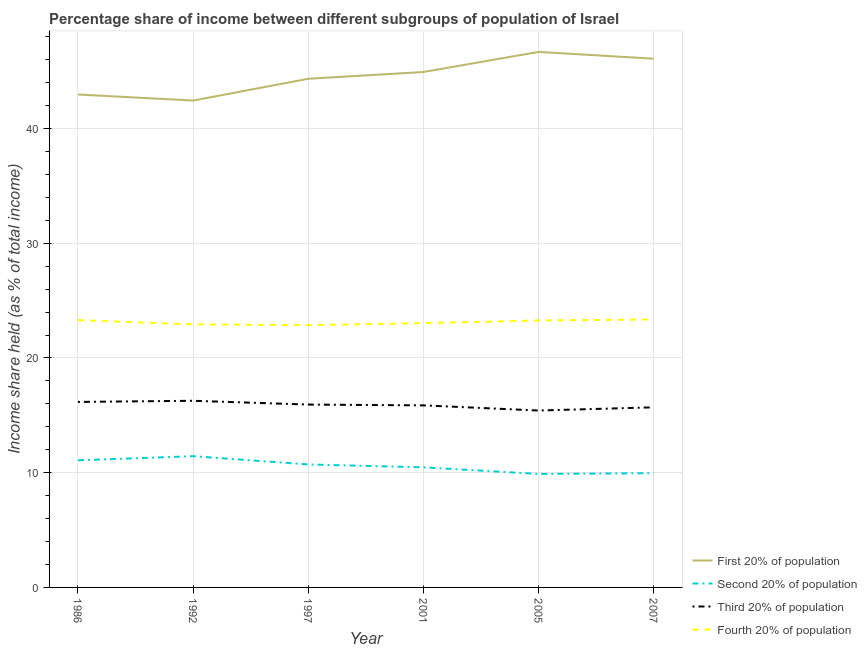Does the line corresponding to share of the income held by third 20% of the population intersect with the line corresponding to share of the income held by second 20% of the population?
Make the answer very short. No. Is the number of lines equal to the number of legend labels?
Your answer should be very brief. Yes. What is the share of the income held by fourth 20% of the population in 2001?
Keep it short and to the point. 23.04. Across all years, what is the maximum share of the income held by first 20% of the population?
Your answer should be very brief. 46.68. Across all years, what is the minimum share of the income held by third 20% of the population?
Provide a succinct answer. 15.42. In which year was the share of the income held by third 20% of the population maximum?
Offer a very short reply. 1992. In which year was the share of the income held by third 20% of the population minimum?
Offer a very short reply. 2005. What is the total share of the income held by third 20% of the population in the graph?
Keep it short and to the point. 95.37. What is the difference between the share of the income held by fourth 20% of the population in 1986 and that in 1992?
Keep it short and to the point. 0.37. What is the difference between the share of the income held by second 20% of the population in 1992 and the share of the income held by first 20% of the population in 2001?
Provide a short and direct response. -33.49. What is the average share of the income held by fourth 20% of the population per year?
Provide a succinct answer. 23.13. In the year 2001, what is the difference between the share of the income held by first 20% of the population and share of the income held by second 20% of the population?
Provide a succinct answer. 34.46. What is the ratio of the share of the income held by third 20% of the population in 2001 to that in 2007?
Keep it short and to the point. 1.01. What is the difference between the highest and the second highest share of the income held by fourth 20% of the population?
Offer a terse response. 0.06. What is the difference between the highest and the lowest share of the income held by third 20% of the population?
Offer a terse response. 0.85. Is it the case that in every year, the sum of the share of the income held by first 20% of the population and share of the income held by second 20% of the population is greater than the share of the income held by third 20% of the population?
Provide a short and direct response. Yes. Is the share of the income held by first 20% of the population strictly less than the share of the income held by third 20% of the population over the years?
Your response must be concise. No. How many lines are there?
Make the answer very short. 4. What is the difference between two consecutive major ticks on the Y-axis?
Provide a short and direct response. 10. Are the values on the major ticks of Y-axis written in scientific E-notation?
Offer a very short reply. No. Does the graph contain any zero values?
Provide a succinct answer. No. Does the graph contain grids?
Make the answer very short. Yes. How are the legend labels stacked?
Ensure brevity in your answer.  Vertical. What is the title of the graph?
Ensure brevity in your answer.  Percentage share of income between different subgroups of population of Israel. Does "Korea" appear as one of the legend labels in the graph?
Ensure brevity in your answer.  No. What is the label or title of the Y-axis?
Ensure brevity in your answer.  Income share held (as % of total income). What is the Income share held (as % of total income) in First 20% of population in 1986?
Provide a succinct answer. 42.97. What is the Income share held (as % of total income) in Second 20% of population in 1986?
Offer a very short reply. 11.08. What is the Income share held (as % of total income) of Third 20% of population in 1986?
Give a very brief answer. 16.17. What is the Income share held (as % of total income) in Fourth 20% of population in 1986?
Your response must be concise. 23.3. What is the Income share held (as % of total income) in First 20% of population in 1992?
Provide a short and direct response. 42.44. What is the Income share held (as % of total income) in Second 20% of population in 1992?
Ensure brevity in your answer.  11.44. What is the Income share held (as % of total income) of Third 20% of population in 1992?
Ensure brevity in your answer.  16.27. What is the Income share held (as % of total income) of Fourth 20% of population in 1992?
Offer a very short reply. 22.93. What is the Income share held (as % of total income) in First 20% of population in 1997?
Give a very brief answer. 44.34. What is the Income share held (as % of total income) in Second 20% of population in 1997?
Ensure brevity in your answer.  10.72. What is the Income share held (as % of total income) of Third 20% of population in 1997?
Your answer should be compact. 15.94. What is the Income share held (as % of total income) of Fourth 20% of population in 1997?
Your answer should be compact. 22.86. What is the Income share held (as % of total income) of First 20% of population in 2001?
Offer a terse response. 44.93. What is the Income share held (as % of total income) of Second 20% of population in 2001?
Give a very brief answer. 10.47. What is the Income share held (as % of total income) of Third 20% of population in 2001?
Keep it short and to the point. 15.87. What is the Income share held (as % of total income) of Fourth 20% of population in 2001?
Ensure brevity in your answer.  23.04. What is the Income share held (as % of total income) of First 20% of population in 2005?
Keep it short and to the point. 46.68. What is the Income share held (as % of total income) in Second 20% of population in 2005?
Your answer should be compact. 9.89. What is the Income share held (as % of total income) in Third 20% of population in 2005?
Offer a terse response. 15.42. What is the Income share held (as % of total income) of Fourth 20% of population in 2005?
Offer a very short reply. 23.27. What is the Income share held (as % of total income) in First 20% of population in 2007?
Your answer should be compact. 46.09. What is the Income share held (as % of total income) in Second 20% of population in 2007?
Ensure brevity in your answer.  9.96. What is the Income share held (as % of total income) of Third 20% of population in 2007?
Provide a short and direct response. 15.7. What is the Income share held (as % of total income) of Fourth 20% of population in 2007?
Provide a succinct answer. 23.36. Across all years, what is the maximum Income share held (as % of total income) in First 20% of population?
Your answer should be very brief. 46.68. Across all years, what is the maximum Income share held (as % of total income) of Second 20% of population?
Provide a succinct answer. 11.44. Across all years, what is the maximum Income share held (as % of total income) in Third 20% of population?
Your response must be concise. 16.27. Across all years, what is the maximum Income share held (as % of total income) of Fourth 20% of population?
Offer a terse response. 23.36. Across all years, what is the minimum Income share held (as % of total income) in First 20% of population?
Your response must be concise. 42.44. Across all years, what is the minimum Income share held (as % of total income) in Second 20% of population?
Your response must be concise. 9.89. Across all years, what is the minimum Income share held (as % of total income) in Third 20% of population?
Provide a succinct answer. 15.42. Across all years, what is the minimum Income share held (as % of total income) in Fourth 20% of population?
Make the answer very short. 22.86. What is the total Income share held (as % of total income) in First 20% of population in the graph?
Offer a terse response. 267.45. What is the total Income share held (as % of total income) of Second 20% of population in the graph?
Ensure brevity in your answer.  63.56. What is the total Income share held (as % of total income) in Third 20% of population in the graph?
Make the answer very short. 95.37. What is the total Income share held (as % of total income) of Fourth 20% of population in the graph?
Offer a very short reply. 138.76. What is the difference between the Income share held (as % of total income) of First 20% of population in 1986 and that in 1992?
Your answer should be very brief. 0.53. What is the difference between the Income share held (as % of total income) of Second 20% of population in 1986 and that in 1992?
Provide a succinct answer. -0.36. What is the difference between the Income share held (as % of total income) of Third 20% of population in 1986 and that in 1992?
Give a very brief answer. -0.1. What is the difference between the Income share held (as % of total income) in Fourth 20% of population in 1986 and that in 1992?
Make the answer very short. 0.37. What is the difference between the Income share held (as % of total income) of First 20% of population in 1986 and that in 1997?
Offer a very short reply. -1.37. What is the difference between the Income share held (as % of total income) in Second 20% of population in 1986 and that in 1997?
Give a very brief answer. 0.36. What is the difference between the Income share held (as % of total income) of Third 20% of population in 1986 and that in 1997?
Your response must be concise. 0.23. What is the difference between the Income share held (as % of total income) of Fourth 20% of population in 1986 and that in 1997?
Make the answer very short. 0.44. What is the difference between the Income share held (as % of total income) in First 20% of population in 1986 and that in 2001?
Your answer should be very brief. -1.96. What is the difference between the Income share held (as % of total income) in Second 20% of population in 1986 and that in 2001?
Provide a short and direct response. 0.61. What is the difference between the Income share held (as % of total income) of Fourth 20% of population in 1986 and that in 2001?
Provide a succinct answer. 0.26. What is the difference between the Income share held (as % of total income) of First 20% of population in 1986 and that in 2005?
Your answer should be compact. -3.71. What is the difference between the Income share held (as % of total income) in Second 20% of population in 1986 and that in 2005?
Keep it short and to the point. 1.19. What is the difference between the Income share held (as % of total income) of Fourth 20% of population in 1986 and that in 2005?
Offer a very short reply. 0.03. What is the difference between the Income share held (as % of total income) in First 20% of population in 1986 and that in 2007?
Keep it short and to the point. -3.12. What is the difference between the Income share held (as % of total income) in Second 20% of population in 1986 and that in 2007?
Make the answer very short. 1.12. What is the difference between the Income share held (as % of total income) of Third 20% of population in 1986 and that in 2007?
Ensure brevity in your answer.  0.47. What is the difference between the Income share held (as % of total income) of Fourth 20% of population in 1986 and that in 2007?
Offer a terse response. -0.06. What is the difference between the Income share held (as % of total income) of First 20% of population in 1992 and that in 1997?
Provide a short and direct response. -1.9. What is the difference between the Income share held (as % of total income) in Second 20% of population in 1992 and that in 1997?
Make the answer very short. 0.72. What is the difference between the Income share held (as % of total income) of Third 20% of population in 1992 and that in 1997?
Give a very brief answer. 0.33. What is the difference between the Income share held (as % of total income) in Fourth 20% of population in 1992 and that in 1997?
Provide a succinct answer. 0.07. What is the difference between the Income share held (as % of total income) of First 20% of population in 1992 and that in 2001?
Offer a terse response. -2.49. What is the difference between the Income share held (as % of total income) of Second 20% of population in 1992 and that in 2001?
Keep it short and to the point. 0.97. What is the difference between the Income share held (as % of total income) in Fourth 20% of population in 1992 and that in 2001?
Your answer should be very brief. -0.11. What is the difference between the Income share held (as % of total income) in First 20% of population in 1992 and that in 2005?
Ensure brevity in your answer.  -4.24. What is the difference between the Income share held (as % of total income) of Second 20% of population in 1992 and that in 2005?
Ensure brevity in your answer.  1.55. What is the difference between the Income share held (as % of total income) of Third 20% of population in 1992 and that in 2005?
Keep it short and to the point. 0.85. What is the difference between the Income share held (as % of total income) in Fourth 20% of population in 1992 and that in 2005?
Your answer should be compact. -0.34. What is the difference between the Income share held (as % of total income) of First 20% of population in 1992 and that in 2007?
Keep it short and to the point. -3.65. What is the difference between the Income share held (as % of total income) in Second 20% of population in 1992 and that in 2007?
Keep it short and to the point. 1.48. What is the difference between the Income share held (as % of total income) of Third 20% of population in 1992 and that in 2007?
Your response must be concise. 0.57. What is the difference between the Income share held (as % of total income) of Fourth 20% of population in 1992 and that in 2007?
Offer a very short reply. -0.43. What is the difference between the Income share held (as % of total income) in First 20% of population in 1997 and that in 2001?
Provide a succinct answer. -0.59. What is the difference between the Income share held (as % of total income) in Second 20% of population in 1997 and that in 2001?
Offer a very short reply. 0.25. What is the difference between the Income share held (as % of total income) of Third 20% of population in 1997 and that in 2001?
Make the answer very short. 0.07. What is the difference between the Income share held (as % of total income) of Fourth 20% of population in 1997 and that in 2001?
Your response must be concise. -0.18. What is the difference between the Income share held (as % of total income) in First 20% of population in 1997 and that in 2005?
Keep it short and to the point. -2.34. What is the difference between the Income share held (as % of total income) of Second 20% of population in 1997 and that in 2005?
Offer a terse response. 0.83. What is the difference between the Income share held (as % of total income) of Third 20% of population in 1997 and that in 2005?
Make the answer very short. 0.52. What is the difference between the Income share held (as % of total income) of Fourth 20% of population in 1997 and that in 2005?
Keep it short and to the point. -0.41. What is the difference between the Income share held (as % of total income) of First 20% of population in 1997 and that in 2007?
Your response must be concise. -1.75. What is the difference between the Income share held (as % of total income) of Second 20% of population in 1997 and that in 2007?
Provide a short and direct response. 0.76. What is the difference between the Income share held (as % of total income) of Third 20% of population in 1997 and that in 2007?
Make the answer very short. 0.24. What is the difference between the Income share held (as % of total income) in Fourth 20% of population in 1997 and that in 2007?
Provide a succinct answer. -0.5. What is the difference between the Income share held (as % of total income) of First 20% of population in 2001 and that in 2005?
Offer a terse response. -1.75. What is the difference between the Income share held (as % of total income) of Second 20% of population in 2001 and that in 2005?
Offer a very short reply. 0.58. What is the difference between the Income share held (as % of total income) in Third 20% of population in 2001 and that in 2005?
Offer a very short reply. 0.45. What is the difference between the Income share held (as % of total income) in Fourth 20% of population in 2001 and that in 2005?
Ensure brevity in your answer.  -0.23. What is the difference between the Income share held (as % of total income) of First 20% of population in 2001 and that in 2007?
Offer a terse response. -1.16. What is the difference between the Income share held (as % of total income) in Second 20% of population in 2001 and that in 2007?
Your response must be concise. 0.51. What is the difference between the Income share held (as % of total income) of Third 20% of population in 2001 and that in 2007?
Your answer should be compact. 0.17. What is the difference between the Income share held (as % of total income) of Fourth 20% of population in 2001 and that in 2007?
Your answer should be compact. -0.32. What is the difference between the Income share held (as % of total income) of First 20% of population in 2005 and that in 2007?
Provide a succinct answer. 0.59. What is the difference between the Income share held (as % of total income) of Second 20% of population in 2005 and that in 2007?
Offer a terse response. -0.07. What is the difference between the Income share held (as % of total income) of Third 20% of population in 2005 and that in 2007?
Make the answer very short. -0.28. What is the difference between the Income share held (as % of total income) of Fourth 20% of population in 2005 and that in 2007?
Your answer should be compact. -0.09. What is the difference between the Income share held (as % of total income) in First 20% of population in 1986 and the Income share held (as % of total income) in Second 20% of population in 1992?
Provide a succinct answer. 31.53. What is the difference between the Income share held (as % of total income) of First 20% of population in 1986 and the Income share held (as % of total income) of Third 20% of population in 1992?
Your answer should be very brief. 26.7. What is the difference between the Income share held (as % of total income) of First 20% of population in 1986 and the Income share held (as % of total income) of Fourth 20% of population in 1992?
Your answer should be very brief. 20.04. What is the difference between the Income share held (as % of total income) in Second 20% of population in 1986 and the Income share held (as % of total income) in Third 20% of population in 1992?
Your answer should be very brief. -5.19. What is the difference between the Income share held (as % of total income) in Second 20% of population in 1986 and the Income share held (as % of total income) in Fourth 20% of population in 1992?
Offer a very short reply. -11.85. What is the difference between the Income share held (as % of total income) in Third 20% of population in 1986 and the Income share held (as % of total income) in Fourth 20% of population in 1992?
Offer a very short reply. -6.76. What is the difference between the Income share held (as % of total income) in First 20% of population in 1986 and the Income share held (as % of total income) in Second 20% of population in 1997?
Give a very brief answer. 32.25. What is the difference between the Income share held (as % of total income) in First 20% of population in 1986 and the Income share held (as % of total income) in Third 20% of population in 1997?
Your response must be concise. 27.03. What is the difference between the Income share held (as % of total income) in First 20% of population in 1986 and the Income share held (as % of total income) in Fourth 20% of population in 1997?
Offer a terse response. 20.11. What is the difference between the Income share held (as % of total income) in Second 20% of population in 1986 and the Income share held (as % of total income) in Third 20% of population in 1997?
Keep it short and to the point. -4.86. What is the difference between the Income share held (as % of total income) in Second 20% of population in 1986 and the Income share held (as % of total income) in Fourth 20% of population in 1997?
Give a very brief answer. -11.78. What is the difference between the Income share held (as % of total income) in Third 20% of population in 1986 and the Income share held (as % of total income) in Fourth 20% of population in 1997?
Provide a succinct answer. -6.69. What is the difference between the Income share held (as % of total income) of First 20% of population in 1986 and the Income share held (as % of total income) of Second 20% of population in 2001?
Provide a succinct answer. 32.5. What is the difference between the Income share held (as % of total income) in First 20% of population in 1986 and the Income share held (as % of total income) in Third 20% of population in 2001?
Your answer should be compact. 27.1. What is the difference between the Income share held (as % of total income) of First 20% of population in 1986 and the Income share held (as % of total income) of Fourth 20% of population in 2001?
Offer a very short reply. 19.93. What is the difference between the Income share held (as % of total income) of Second 20% of population in 1986 and the Income share held (as % of total income) of Third 20% of population in 2001?
Your answer should be compact. -4.79. What is the difference between the Income share held (as % of total income) in Second 20% of population in 1986 and the Income share held (as % of total income) in Fourth 20% of population in 2001?
Your answer should be compact. -11.96. What is the difference between the Income share held (as % of total income) of Third 20% of population in 1986 and the Income share held (as % of total income) of Fourth 20% of population in 2001?
Provide a succinct answer. -6.87. What is the difference between the Income share held (as % of total income) in First 20% of population in 1986 and the Income share held (as % of total income) in Second 20% of population in 2005?
Provide a short and direct response. 33.08. What is the difference between the Income share held (as % of total income) of First 20% of population in 1986 and the Income share held (as % of total income) of Third 20% of population in 2005?
Give a very brief answer. 27.55. What is the difference between the Income share held (as % of total income) in Second 20% of population in 1986 and the Income share held (as % of total income) in Third 20% of population in 2005?
Ensure brevity in your answer.  -4.34. What is the difference between the Income share held (as % of total income) of Second 20% of population in 1986 and the Income share held (as % of total income) of Fourth 20% of population in 2005?
Offer a very short reply. -12.19. What is the difference between the Income share held (as % of total income) of Third 20% of population in 1986 and the Income share held (as % of total income) of Fourth 20% of population in 2005?
Offer a very short reply. -7.1. What is the difference between the Income share held (as % of total income) of First 20% of population in 1986 and the Income share held (as % of total income) of Second 20% of population in 2007?
Make the answer very short. 33.01. What is the difference between the Income share held (as % of total income) of First 20% of population in 1986 and the Income share held (as % of total income) of Third 20% of population in 2007?
Your answer should be compact. 27.27. What is the difference between the Income share held (as % of total income) in First 20% of population in 1986 and the Income share held (as % of total income) in Fourth 20% of population in 2007?
Keep it short and to the point. 19.61. What is the difference between the Income share held (as % of total income) in Second 20% of population in 1986 and the Income share held (as % of total income) in Third 20% of population in 2007?
Provide a short and direct response. -4.62. What is the difference between the Income share held (as % of total income) of Second 20% of population in 1986 and the Income share held (as % of total income) of Fourth 20% of population in 2007?
Your answer should be compact. -12.28. What is the difference between the Income share held (as % of total income) of Third 20% of population in 1986 and the Income share held (as % of total income) of Fourth 20% of population in 2007?
Make the answer very short. -7.19. What is the difference between the Income share held (as % of total income) in First 20% of population in 1992 and the Income share held (as % of total income) in Second 20% of population in 1997?
Your answer should be very brief. 31.72. What is the difference between the Income share held (as % of total income) of First 20% of population in 1992 and the Income share held (as % of total income) of Third 20% of population in 1997?
Keep it short and to the point. 26.5. What is the difference between the Income share held (as % of total income) of First 20% of population in 1992 and the Income share held (as % of total income) of Fourth 20% of population in 1997?
Your answer should be compact. 19.58. What is the difference between the Income share held (as % of total income) of Second 20% of population in 1992 and the Income share held (as % of total income) of Fourth 20% of population in 1997?
Keep it short and to the point. -11.42. What is the difference between the Income share held (as % of total income) of Third 20% of population in 1992 and the Income share held (as % of total income) of Fourth 20% of population in 1997?
Make the answer very short. -6.59. What is the difference between the Income share held (as % of total income) in First 20% of population in 1992 and the Income share held (as % of total income) in Second 20% of population in 2001?
Keep it short and to the point. 31.97. What is the difference between the Income share held (as % of total income) in First 20% of population in 1992 and the Income share held (as % of total income) in Third 20% of population in 2001?
Your answer should be very brief. 26.57. What is the difference between the Income share held (as % of total income) in Second 20% of population in 1992 and the Income share held (as % of total income) in Third 20% of population in 2001?
Your response must be concise. -4.43. What is the difference between the Income share held (as % of total income) in Second 20% of population in 1992 and the Income share held (as % of total income) in Fourth 20% of population in 2001?
Keep it short and to the point. -11.6. What is the difference between the Income share held (as % of total income) of Third 20% of population in 1992 and the Income share held (as % of total income) of Fourth 20% of population in 2001?
Keep it short and to the point. -6.77. What is the difference between the Income share held (as % of total income) of First 20% of population in 1992 and the Income share held (as % of total income) of Second 20% of population in 2005?
Your response must be concise. 32.55. What is the difference between the Income share held (as % of total income) of First 20% of population in 1992 and the Income share held (as % of total income) of Third 20% of population in 2005?
Your response must be concise. 27.02. What is the difference between the Income share held (as % of total income) in First 20% of population in 1992 and the Income share held (as % of total income) in Fourth 20% of population in 2005?
Give a very brief answer. 19.17. What is the difference between the Income share held (as % of total income) of Second 20% of population in 1992 and the Income share held (as % of total income) of Third 20% of population in 2005?
Your answer should be compact. -3.98. What is the difference between the Income share held (as % of total income) of Second 20% of population in 1992 and the Income share held (as % of total income) of Fourth 20% of population in 2005?
Give a very brief answer. -11.83. What is the difference between the Income share held (as % of total income) of Third 20% of population in 1992 and the Income share held (as % of total income) of Fourth 20% of population in 2005?
Offer a very short reply. -7. What is the difference between the Income share held (as % of total income) in First 20% of population in 1992 and the Income share held (as % of total income) in Second 20% of population in 2007?
Keep it short and to the point. 32.48. What is the difference between the Income share held (as % of total income) in First 20% of population in 1992 and the Income share held (as % of total income) in Third 20% of population in 2007?
Your answer should be compact. 26.74. What is the difference between the Income share held (as % of total income) in First 20% of population in 1992 and the Income share held (as % of total income) in Fourth 20% of population in 2007?
Your answer should be compact. 19.08. What is the difference between the Income share held (as % of total income) of Second 20% of population in 1992 and the Income share held (as % of total income) of Third 20% of population in 2007?
Your answer should be compact. -4.26. What is the difference between the Income share held (as % of total income) in Second 20% of population in 1992 and the Income share held (as % of total income) in Fourth 20% of population in 2007?
Provide a succinct answer. -11.92. What is the difference between the Income share held (as % of total income) in Third 20% of population in 1992 and the Income share held (as % of total income) in Fourth 20% of population in 2007?
Your response must be concise. -7.09. What is the difference between the Income share held (as % of total income) of First 20% of population in 1997 and the Income share held (as % of total income) of Second 20% of population in 2001?
Provide a succinct answer. 33.87. What is the difference between the Income share held (as % of total income) of First 20% of population in 1997 and the Income share held (as % of total income) of Third 20% of population in 2001?
Your response must be concise. 28.47. What is the difference between the Income share held (as % of total income) of First 20% of population in 1997 and the Income share held (as % of total income) of Fourth 20% of population in 2001?
Your answer should be compact. 21.3. What is the difference between the Income share held (as % of total income) of Second 20% of population in 1997 and the Income share held (as % of total income) of Third 20% of population in 2001?
Give a very brief answer. -5.15. What is the difference between the Income share held (as % of total income) of Second 20% of population in 1997 and the Income share held (as % of total income) of Fourth 20% of population in 2001?
Your answer should be very brief. -12.32. What is the difference between the Income share held (as % of total income) in First 20% of population in 1997 and the Income share held (as % of total income) in Second 20% of population in 2005?
Keep it short and to the point. 34.45. What is the difference between the Income share held (as % of total income) of First 20% of population in 1997 and the Income share held (as % of total income) of Third 20% of population in 2005?
Your answer should be very brief. 28.92. What is the difference between the Income share held (as % of total income) of First 20% of population in 1997 and the Income share held (as % of total income) of Fourth 20% of population in 2005?
Your answer should be very brief. 21.07. What is the difference between the Income share held (as % of total income) of Second 20% of population in 1997 and the Income share held (as % of total income) of Third 20% of population in 2005?
Provide a short and direct response. -4.7. What is the difference between the Income share held (as % of total income) of Second 20% of population in 1997 and the Income share held (as % of total income) of Fourth 20% of population in 2005?
Make the answer very short. -12.55. What is the difference between the Income share held (as % of total income) of Third 20% of population in 1997 and the Income share held (as % of total income) of Fourth 20% of population in 2005?
Provide a short and direct response. -7.33. What is the difference between the Income share held (as % of total income) in First 20% of population in 1997 and the Income share held (as % of total income) in Second 20% of population in 2007?
Offer a terse response. 34.38. What is the difference between the Income share held (as % of total income) in First 20% of population in 1997 and the Income share held (as % of total income) in Third 20% of population in 2007?
Ensure brevity in your answer.  28.64. What is the difference between the Income share held (as % of total income) of First 20% of population in 1997 and the Income share held (as % of total income) of Fourth 20% of population in 2007?
Provide a short and direct response. 20.98. What is the difference between the Income share held (as % of total income) in Second 20% of population in 1997 and the Income share held (as % of total income) in Third 20% of population in 2007?
Offer a very short reply. -4.98. What is the difference between the Income share held (as % of total income) of Second 20% of population in 1997 and the Income share held (as % of total income) of Fourth 20% of population in 2007?
Give a very brief answer. -12.64. What is the difference between the Income share held (as % of total income) of Third 20% of population in 1997 and the Income share held (as % of total income) of Fourth 20% of population in 2007?
Make the answer very short. -7.42. What is the difference between the Income share held (as % of total income) in First 20% of population in 2001 and the Income share held (as % of total income) in Second 20% of population in 2005?
Offer a terse response. 35.04. What is the difference between the Income share held (as % of total income) of First 20% of population in 2001 and the Income share held (as % of total income) of Third 20% of population in 2005?
Provide a succinct answer. 29.51. What is the difference between the Income share held (as % of total income) in First 20% of population in 2001 and the Income share held (as % of total income) in Fourth 20% of population in 2005?
Ensure brevity in your answer.  21.66. What is the difference between the Income share held (as % of total income) of Second 20% of population in 2001 and the Income share held (as % of total income) of Third 20% of population in 2005?
Offer a very short reply. -4.95. What is the difference between the Income share held (as % of total income) in First 20% of population in 2001 and the Income share held (as % of total income) in Second 20% of population in 2007?
Your response must be concise. 34.97. What is the difference between the Income share held (as % of total income) in First 20% of population in 2001 and the Income share held (as % of total income) in Third 20% of population in 2007?
Keep it short and to the point. 29.23. What is the difference between the Income share held (as % of total income) of First 20% of population in 2001 and the Income share held (as % of total income) of Fourth 20% of population in 2007?
Offer a very short reply. 21.57. What is the difference between the Income share held (as % of total income) in Second 20% of population in 2001 and the Income share held (as % of total income) in Third 20% of population in 2007?
Give a very brief answer. -5.23. What is the difference between the Income share held (as % of total income) of Second 20% of population in 2001 and the Income share held (as % of total income) of Fourth 20% of population in 2007?
Your answer should be very brief. -12.89. What is the difference between the Income share held (as % of total income) of Third 20% of population in 2001 and the Income share held (as % of total income) of Fourth 20% of population in 2007?
Offer a terse response. -7.49. What is the difference between the Income share held (as % of total income) of First 20% of population in 2005 and the Income share held (as % of total income) of Second 20% of population in 2007?
Your response must be concise. 36.72. What is the difference between the Income share held (as % of total income) in First 20% of population in 2005 and the Income share held (as % of total income) in Third 20% of population in 2007?
Your answer should be very brief. 30.98. What is the difference between the Income share held (as % of total income) in First 20% of population in 2005 and the Income share held (as % of total income) in Fourth 20% of population in 2007?
Keep it short and to the point. 23.32. What is the difference between the Income share held (as % of total income) in Second 20% of population in 2005 and the Income share held (as % of total income) in Third 20% of population in 2007?
Your response must be concise. -5.81. What is the difference between the Income share held (as % of total income) of Second 20% of population in 2005 and the Income share held (as % of total income) of Fourth 20% of population in 2007?
Offer a terse response. -13.47. What is the difference between the Income share held (as % of total income) in Third 20% of population in 2005 and the Income share held (as % of total income) in Fourth 20% of population in 2007?
Provide a short and direct response. -7.94. What is the average Income share held (as % of total income) of First 20% of population per year?
Provide a succinct answer. 44.58. What is the average Income share held (as % of total income) in Second 20% of population per year?
Keep it short and to the point. 10.59. What is the average Income share held (as % of total income) of Third 20% of population per year?
Provide a short and direct response. 15.89. What is the average Income share held (as % of total income) of Fourth 20% of population per year?
Make the answer very short. 23.13. In the year 1986, what is the difference between the Income share held (as % of total income) in First 20% of population and Income share held (as % of total income) in Second 20% of population?
Offer a terse response. 31.89. In the year 1986, what is the difference between the Income share held (as % of total income) in First 20% of population and Income share held (as % of total income) in Third 20% of population?
Keep it short and to the point. 26.8. In the year 1986, what is the difference between the Income share held (as % of total income) in First 20% of population and Income share held (as % of total income) in Fourth 20% of population?
Your response must be concise. 19.67. In the year 1986, what is the difference between the Income share held (as % of total income) of Second 20% of population and Income share held (as % of total income) of Third 20% of population?
Provide a succinct answer. -5.09. In the year 1986, what is the difference between the Income share held (as % of total income) of Second 20% of population and Income share held (as % of total income) of Fourth 20% of population?
Give a very brief answer. -12.22. In the year 1986, what is the difference between the Income share held (as % of total income) of Third 20% of population and Income share held (as % of total income) of Fourth 20% of population?
Keep it short and to the point. -7.13. In the year 1992, what is the difference between the Income share held (as % of total income) in First 20% of population and Income share held (as % of total income) in Second 20% of population?
Offer a terse response. 31. In the year 1992, what is the difference between the Income share held (as % of total income) of First 20% of population and Income share held (as % of total income) of Third 20% of population?
Offer a terse response. 26.17. In the year 1992, what is the difference between the Income share held (as % of total income) in First 20% of population and Income share held (as % of total income) in Fourth 20% of population?
Your response must be concise. 19.51. In the year 1992, what is the difference between the Income share held (as % of total income) in Second 20% of population and Income share held (as % of total income) in Third 20% of population?
Keep it short and to the point. -4.83. In the year 1992, what is the difference between the Income share held (as % of total income) of Second 20% of population and Income share held (as % of total income) of Fourth 20% of population?
Provide a short and direct response. -11.49. In the year 1992, what is the difference between the Income share held (as % of total income) in Third 20% of population and Income share held (as % of total income) in Fourth 20% of population?
Ensure brevity in your answer.  -6.66. In the year 1997, what is the difference between the Income share held (as % of total income) of First 20% of population and Income share held (as % of total income) of Second 20% of population?
Give a very brief answer. 33.62. In the year 1997, what is the difference between the Income share held (as % of total income) in First 20% of population and Income share held (as % of total income) in Third 20% of population?
Your answer should be compact. 28.4. In the year 1997, what is the difference between the Income share held (as % of total income) of First 20% of population and Income share held (as % of total income) of Fourth 20% of population?
Offer a terse response. 21.48. In the year 1997, what is the difference between the Income share held (as % of total income) in Second 20% of population and Income share held (as % of total income) in Third 20% of population?
Provide a short and direct response. -5.22. In the year 1997, what is the difference between the Income share held (as % of total income) of Second 20% of population and Income share held (as % of total income) of Fourth 20% of population?
Offer a very short reply. -12.14. In the year 1997, what is the difference between the Income share held (as % of total income) in Third 20% of population and Income share held (as % of total income) in Fourth 20% of population?
Offer a very short reply. -6.92. In the year 2001, what is the difference between the Income share held (as % of total income) of First 20% of population and Income share held (as % of total income) of Second 20% of population?
Provide a succinct answer. 34.46. In the year 2001, what is the difference between the Income share held (as % of total income) in First 20% of population and Income share held (as % of total income) in Third 20% of population?
Your response must be concise. 29.06. In the year 2001, what is the difference between the Income share held (as % of total income) in First 20% of population and Income share held (as % of total income) in Fourth 20% of population?
Provide a short and direct response. 21.89. In the year 2001, what is the difference between the Income share held (as % of total income) of Second 20% of population and Income share held (as % of total income) of Fourth 20% of population?
Offer a very short reply. -12.57. In the year 2001, what is the difference between the Income share held (as % of total income) in Third 20% of population and Income share held (as % of total income) in Fourth 20% of population?
Offer a terse response. -7.17. In the year 2005, what is the difference between the Income share held (as % of total income) in First 20% of population and Income share held (as % of total income) in Second 20% of population?
Give a very brief answer. 36.79. In the year 2005, what is the difference between the Income share held (as % of total income) of First 20% of population and Income share held (as % of total income) of Third 20% of population?
Keep it short and to the point. 31.26. In the year 2005, what is the difference between the Income share held (as % of total income) of First 20% of population and Income share held (as % of total income) of Fourth 20% of population?
Make the answer very short. 23.41. In the year 2005, what is the difference between the Income share held (as % of total income) of Second 20% of population and Income share held (as % of total income) of Third 20% of population?
Keep it short and to the point. -5.53. In the year 2005, what is the difference between the Income share held (as % of total income) in Second 20% of population and Income share held (as % of total income) in Fourth 20% of population?
Your answer should be very brief. -13.38. In the year 2005, what is the difference between the Income share held (as % of total income) in Third 20% of population and Income share held (as % of total income) in Fourth 20% of population?
Your response must be concise. -7.85. In the year 2007, what is the difference between the Income share held (as % of total income) of First 20% of population and Income share held (as % of total income) of Second 20% of population?
Ensure brevity in your answer.  36.13. In the year 2007, what is the difference between the Income share held (as % of total income) of First 20% of population and Income share held (as % of total income) of Third 20% of population?
Offer a terse response. 30.39. In the year 2007, what is the difference between the Income share held (as % of total income) in First 20% of population and Income share held (as % of total income) in Fourth 20% of population?
Provide a short and direct response. 22.73. In the year 2007, what is the difference between the Income share held (as % of total income) in Second 20% of population and Income share held (as % of total income) in Third 20% of population?
Your response must be concise. -5.74. In the year 2007, what is the difference between the Income share held (as % of total income) of Third 20% of population and Income share held (as % of total income) of Fourth 20% of population?
Keep it short and to the point. -7.66. What is the ratio of the Income share held (as % of total income) in First 20% of population in 1986 to that in 1992?
Provide a short and direct response. 1.01. What is the ratio of the Income share held (as % of total income) in Second 20% of population in 1986 to that in 1992?
Make the answer very short. 0.97. What is the ratio of the Income share held (as % of total income) of Third 20% of population in 1986 to that in 1992?
Offer a very short reply. 0.99. What is the ratio of the Income share held (as % of total income) of Fourth 20% of population in 1986 to that in 1992?
Offer a very short reply. 1.02. What is the ratio of the Income share held (as % of total income) of First 20% of population in 1986 to that in 1997?
Keep it short and to the point. 0.97. What is the ratio of the Income share held (as % of total income) in Second 20% of population in 1986 to that in 1997?
Offer a very short reply. 1.03. What is the ratio of the Income share held (as % of total income) of Third 20% of population in 1986 to that in 1997?
Make the answer very short. 1.01. What is the ratio of the Income share held (as % of total income) of Fourth 20% of population in 1986 to that in 1997?
Give a very brief answer. 1.02. What is the ratio of the Income share held (as % of total income) of First 20% of population in 1986 to that in 2001?
Provide a succinct answer. 0.96. What is the ratio of the Income share held (as % of total income) of Second 20% of population in 1986 to that in 2001?
Offer a very short reply. 1.06. What is the ratio of the Income share held (as % of total income) in Third 20% of population in 1986 to that in 2001?
Make the answer very short. 1.02. What is the ratio of the Income share held (as % of total income) of Fourth 20% of population in 1986 to that in 2001?
Your answer should be very brief. 1.01. What is the ratio of the Income share held (as % of total income) of First 20% of population in 1986 to that in 2005?
Keep it short and to the point. 0.92. What is the ratio of the Income share held (as % of total income) of Second 20% of population in 1986 to that in 2005?
Offer a very short reply. 1.12. What is the ratio of the Income share held (as % of total income) of Third 20% of population in 1986 to that in 2005?
Provide a succinct answer. 1.05. What is the ratio of the Income share held (as % of total income) in First 20% of population in 1986 to that in 2007?
Your response must be concise. 0.93. What is the ratio of the Income share held (as % of total income) in Second 20% of population in 1986 to that in 2007?
Provide a succinct answer. 1.11. What is the ratio of the Income share held (as % of total income) in Third 20% of population in 1986 to that in 2007?
Give a very brief answer. 1.03. What is the ratio of the Income share held (as % of total income) in First 20% of population in 1992 to that in 1997?
Offer a very short reply. 0.96. What is the ratio of the Income share held (as % of total income) of Second 20% of population in 1992 to that in 1997?
Your answer should be compact. 1.07. What is the ratio of the Income share held (as % of total income) of Third 20% of population in 1992 to that in 1997?
Give a very brief answer. 1.02. What is the ratio of the Income share held (as % of total income) in First 20% of population in 1992 to that in 2001?
Provide a succinct answer. 0.94. What is the ratio of the Income share held (as % of total income) of Second 20% of population in 1992 to that in 2001?
Provide a succinct answer. 1.09. What is the ratio of the Income share held (as % of total income) of Third 20% of population in 1992 to that in 2001?
Provide a succinct answer. 1.03. What is the ratio of the Income share held (as % of total income) of First 20% of population in 1992 to that in 2005?
Provide a succinct answer. 0.91. What is the ratio of the Income share held (as % of total income) of Second 20% of population in 1992 to that in 2005?
Give a very brief answer. 1.16. What is the ratio of the Income share held (as % of total income) in Third 20% of population in 1992 to that in 2005?
Provide a short and direct response. 1.06. What is the ratio of the Income share held (as % of total income) in Fourth 20% of population in 1992 to that in 2005?
Your response must be concise. 0.99. What is the ratio of the Income share held (as % of total income) in First 20% of population in 1992 to that in 2007?
Your answer should be compact. 0.92. What is the ratio of the Income share held (as % of total income) in Second 20% of population in 1992 to that in 2007?
Offer a terse response. 1.15. What is the ratio of the Income share held (as % of total income) in Third 20% of population in 1992 to that in 2007?
Keep it short and to the point. 1.04. What is the ratio of the Income share held (as % of total income) in Fourth 20% of population in 1992 to that in 2007?
Keep it short and to the point. 0.98. What is the ratio of the Income share held (as % of total income) in First 20% of population in 1997 to that in 2001?
Keep it short and to the point. 0.99. What is the ratio of the Income share held (as % of total income) of Second 20% of population in 1997 to that in 2001?
Provide a succinct answer. 1.02. What is the ratio of the Income share held (as % of total income) in First 20% of population in 1997 to that in 2005?
Ensure brevity in your answer.  0.95. What is the ratio of the Income share held (as % of total income) of Second 20% of population in 1997 to that in 2005?
Make the answer very short. 1.08. What is the ratio of the Income share held (as % of total income) of Third 20% of population in 1997 to that in 2005?
Give a very brief answer. 1.03. What is the ratio of the Income share held (as % of total income) of Fourth 20% of population in 1997 to that in 2005?
Your answer should be compact. 0.98. What is the ratio of the Income share held (as % of total income) in Second 20% of population in 1997 to that in 2007?
Offer a very short reply. 1.08. What is the ratio of the Income share held (as % of total income) in Third 20% of population in 1997 to that in 2007?
Ensure brevity in your answer.  1.02. What is the ratio of the Income share held (as % of total income) in Fourth 20% of population in 1997 to that in 2007?
Your response must be concise. 0.98. What is the ratio of the Income share held (as % of total income) in First 20% of population in 2001 to that in 2005?
Offer a very short reply. 0.96. What is the ratio of the Income share held (as % of total income) in Second 20% of population in 2001 to that in 2005?
Your answer should be very brief. 1.06. What is the ratio of the Income share held (as % of total income) of Third 20% of population in 2001 to that in 2005?
Keep it short and to the point. 1.03. What is the ratio of the Income share held (as % of total income) of Fourth 20% of population in 2001 to that in 2005?
Provide a short and direct response. 0.99. What is the ratio of the Income share held (as % of total income) in First 20% of population in 2001 to that in 2007?
Give a very brief answer. 0.97. What is the ratio of the Income share held (as % of total income) of Second 20% of population in 2001 to that in 2007?
Offer a very short reply. 1.05. What is the ratio of the Income share held (as % of total income) in Third 20% of population in 2001 to that in 2007?
Offer a terse response. 1.01. What is the ratio of the Income share held (as % of total income) in Fourth 20% of population in 2001 to that in 2007?
Provide a short and direct response. 0.99. What is the ratio of the Income share held (as % of total income) of First 20% of population in 2005 to that in 2007?
Offer a terse response. 1.01. What is the ratio of the Income share held (as % of total income) of Second 20% of population in 2005 to that in 2007?
Make the answer very short. 0.99. What is the ratio of the Income share held (as % of total income) in Third 20% of population in 2005 to that in 2007?
Ensure brevity in your answer.  0.98. What is the ratio of the Income share held (as % of total income) of Fourth 20% of population in 2005 to that in 2007?
Your answer should be compact. 1. What is the difference between the highest and the second highest Income share held (as % of total income) of First 20% of population?
Keep it short and to the point. 0.59. What is the difference between the highest and the second highest Income share held (as % of total income) in Second 20% of population?
Give a very brief answer. 0.36. What is the difference between the highest and the second highest Income share held (as % of total income) of Third 20% of population?
Your response must be concise. 0.1. What is the difference between the highest and the lowest Income share held (as % of total income) of First 20% of population?
Your response must be concise. 4.24. What is the difference between the highest and the lowest Income share held (as % of total income) of Second 20% of population?
Offer a very short reply. 1.55. What is the difference between the highest and the lowest Income share held (as % of total income) of Fourth 20% of population?
Ensure brevity in your answer.  0.5. 